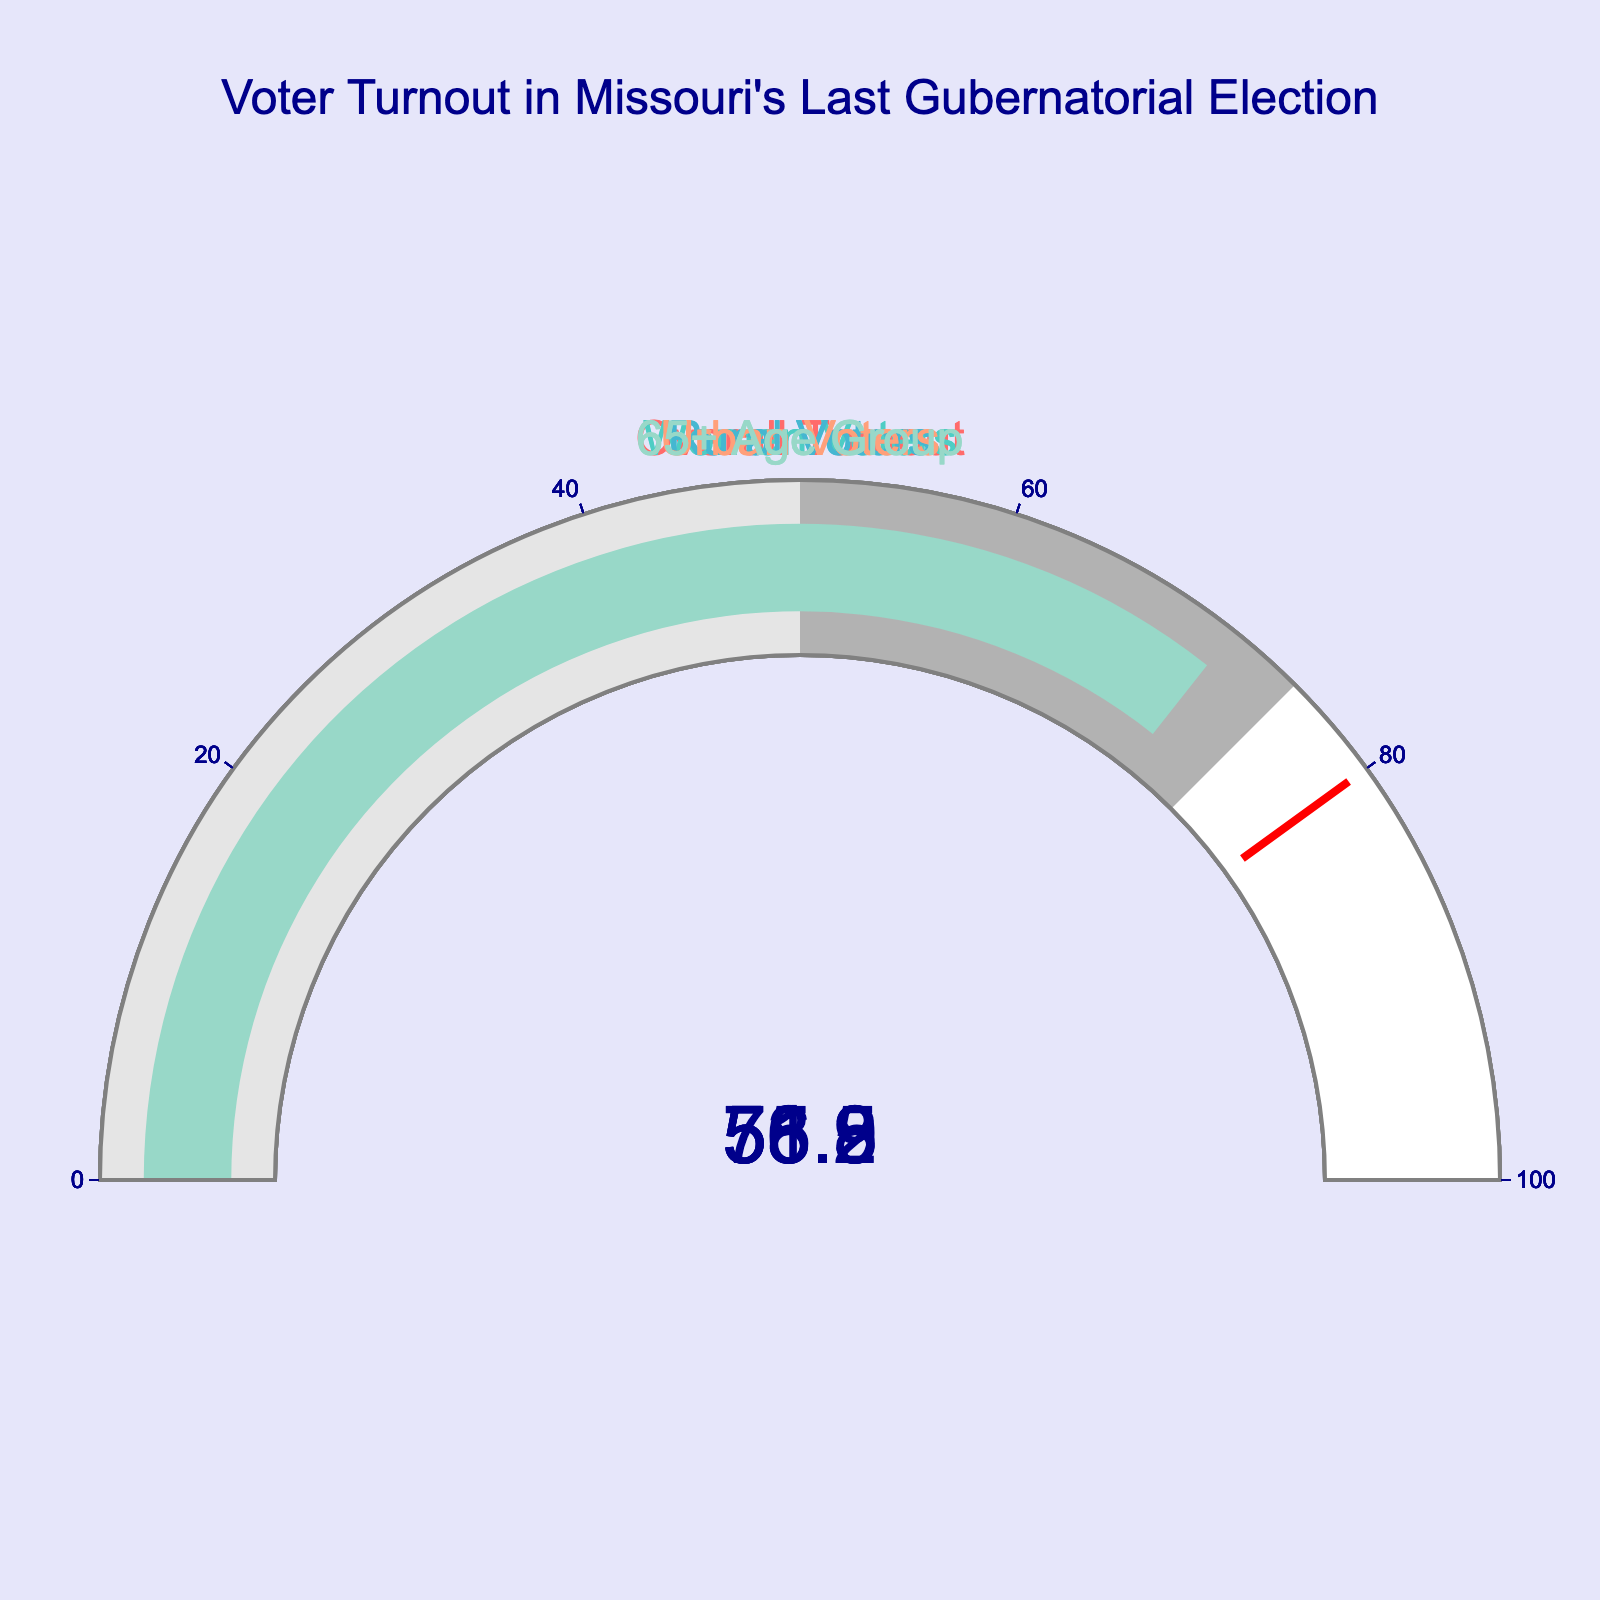What is the overall voter turnout rate in Missouri's last gubernatorial election? Look at the gauge labeled "Overall Turnout." The large number displayed on the gauge indicates the overall voter turnout rate.
Answer: 55.8% Which voter group had the highest turnout rate? Compare all the gauge values to find the highest one. The gauge with the highest number indicates the group with the highest turnout rate.
Answer: 65+ Age Group How much higher is the turnout rate for women voters compared to rural voters? Subtract the turnout rate of rural voters from the turnout rate of women voters.
Answer: 4.7% What is the average turnout rate for urban and rural voters combined? Add the turnout rates for urban and rural voters and then divide the sum by 2.
Answer: 55.2% Is the turnout rate for urban voters greater than the overall turnout rate? Compare the gauge values for urban voters and overall turnout. The gauge for urban voters shows 56.9%, which is higher than the overall turnout of 55.8%.
Answer: Yes What is the difference between the highest and lowest voter turnout rates? Subtract the lowest turnout rate from the highest turnout rate by comparing all gauge values.
Answer: 17.8% Which voter group is closest to the overall turnout rate? Compare the overall turnout rate with each group’s turnout rate to see which one is nearest. Women Voters with 58.2% are closest to the overall rate of 55.8%.
Answer: Women Voters How much does the turnout rate of the 65+ age group exceed the threshold of 80%? Subtract the threshold value of 80% from the turnout rate of the 65+ age group. If the value is negative, the turnout rate does not exceed the threshold.
Answer: Does not exceed What is the combined turnout rate for women and 65+ age group voters? Add the turnout rates for women and 65+ age group voters.
Answer: 129.5% Between urban and rural voters, which group had a lower turnout rate and by how much? Compare the turnout rates for urban and rural voters and find the difference. Rural voters had a turnout of 53.5%, which is lower than urban voters' 56.9%. The difference is 3.4%.
Answer: Rural Voters by 3.4% 